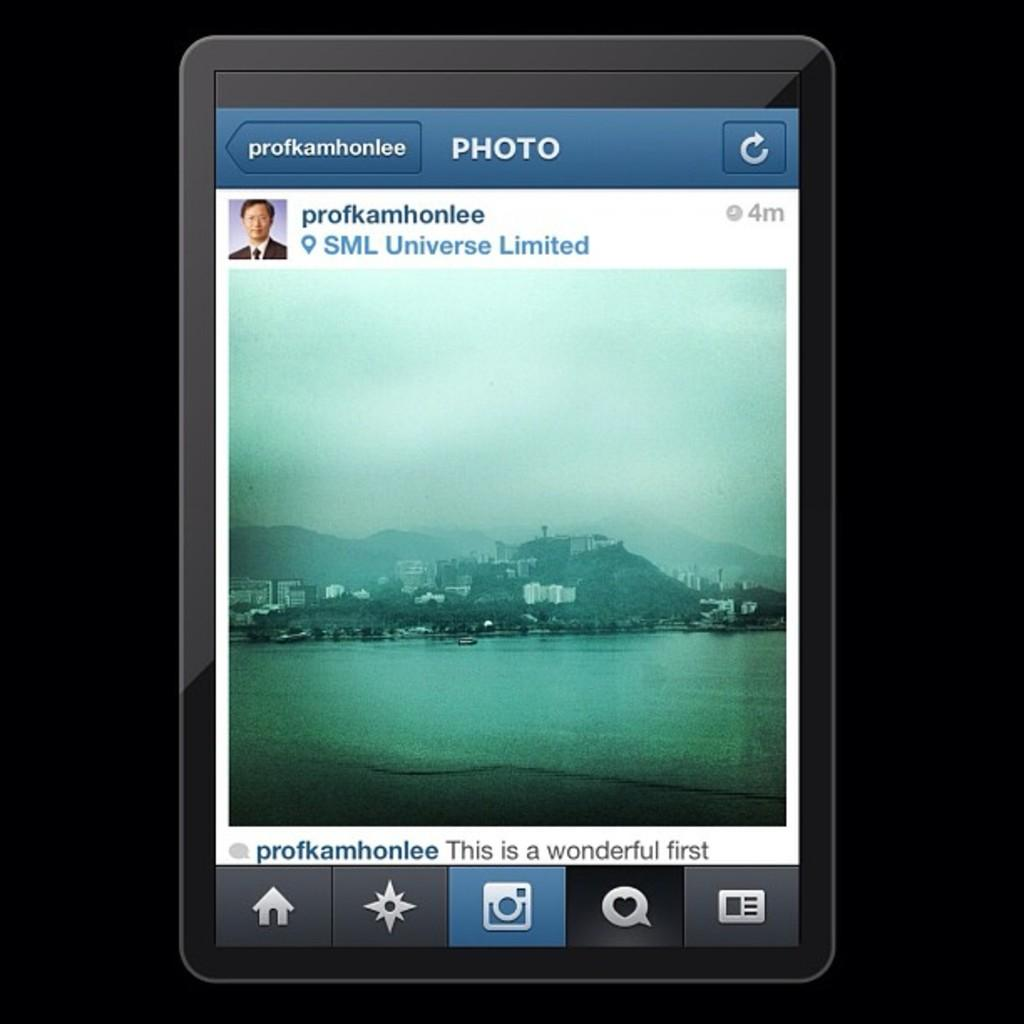Provide a one-sentence caption for the provided image. tablet with a photo posting of an island on it from profkamhonlee. 